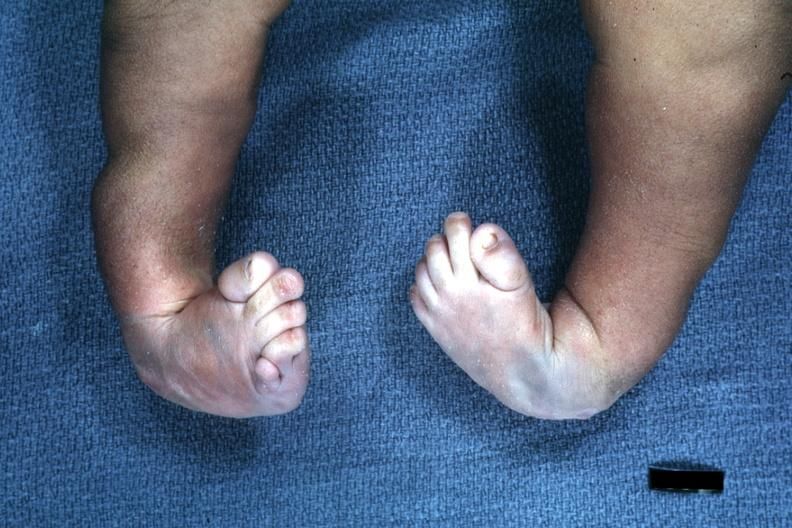what does this image show?
Answer the question using a single word or phrase. Infant with club feet 